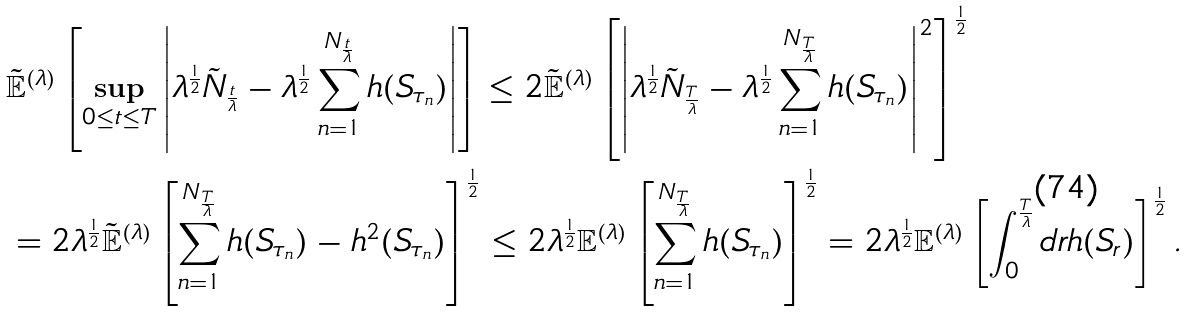Convert formula to latex. <formula><loc_0><loc_0><loc_500><loc_500>& \tilde { \mathbb { E } } ^ { ( \lambda ) } \left [ \sup _ { 0 \leq t \leq T } \left | \lambda ^ { \frac { 1 } { 2 } } \tilde { N } _ { \frac { t } { \lambda } } - \lambda ^ { \frac { 1 } { 2 } } \sum _ { n = 1 } ^ { N _ { \frac { t } { \lambda } } } h ( S _ { \tau _ { n } } ) \right | \right ] \leq 2 \tilde { \mathbb { E } } ^ { ( \lambda ) } \left [ \left | \lambda ^ { \frac { 1 } { 2 } } \tilde { N } _ { \frac { T } { \lambda } } - \lambda ^ { \frac { 1 } { 2 } } \sum _ { n = 1 } ^ { N _ { \frac { T } { \lambda } } } h ( S _ { \tau _ { n } } ) \right | ^ { 2 } \right ] ^ { \frac { 1 } { 2 } } \\ & = 2 \lambda ^ { \frac { 1 } { 2 } } \tilde { \mathbb { E } } ^ { ( \lambda ) } \left [ \sum _ { n = 1 } ^ { N _ { \frac { T } { \lambda } } } h ( S _ { \tau _ { n } } ) - h ^ { 2 } ( S _ { \tau _ { n } } ) \right ] ^ { \frac { 1 } { 2 } } \leq 2 \lambda ^ { \frac { 1 } { 2 } } \mathbb { E } ^ { ( \lambda ) } \left [ \sum _ { n = 1 } ^ { N _ { \frac { T } { \lambda } } } h ( S _ { \tau _ { n } } ) \right ] ^ { \frac { 1 } { 2 } } = 2 \lambda ^ { \frac { 1 } { 2 } } \mathbb { E } ^ { ( \lambda ) } \left [ \int _ { 0 } ^ { \frac { T } { \lambda } } d r h ( S _ { r } ) \right ] ^ { \frac { 1 } { 2 } } .</formula> 